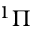<formula> <loc_0><loc_0><loc_500><loc_500>^ { 1 } \Pi</formula> 